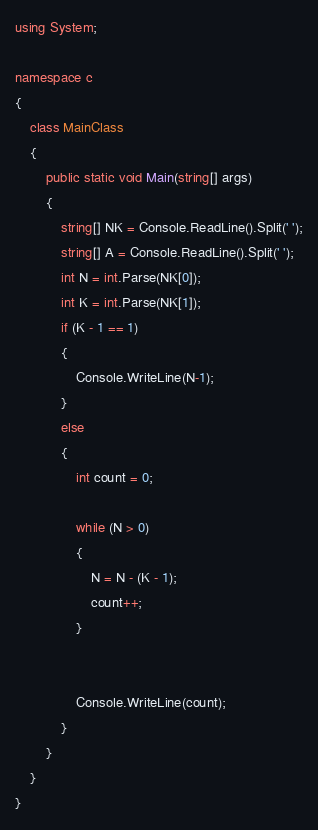<code> <loc_0><loc_0><loc_500><loc_500><_C#_>using System;

namespace c
{
    class MainClass
    {
        public static void Main(string[] args)
        {
            string[] NK = Console.ReadLine().Split(' ');
            string[] A = Console.ReadLine().Split(' ');
            int N = int.Parse(NK[0]);
            int K = int.Parse(NK[1]);
            if (K - 1 == 1)
            {
                Console.WriteLine(N-1);
            }
            else
            {
                int count = 0;

                while (N > 0)
                {
                    N = N - (K - 1);
                    count++;
                }


                Console.WriteLine(count);
            }  
        }
    }
}</code> 